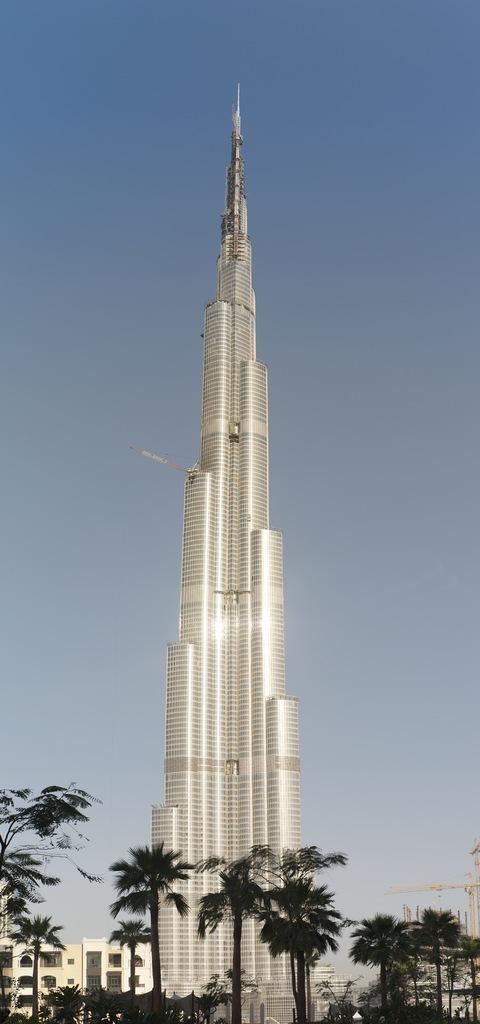Please provide a concise description of this image. In this picture we can see a tower, buildings and trees and in the background we can see the sky. 